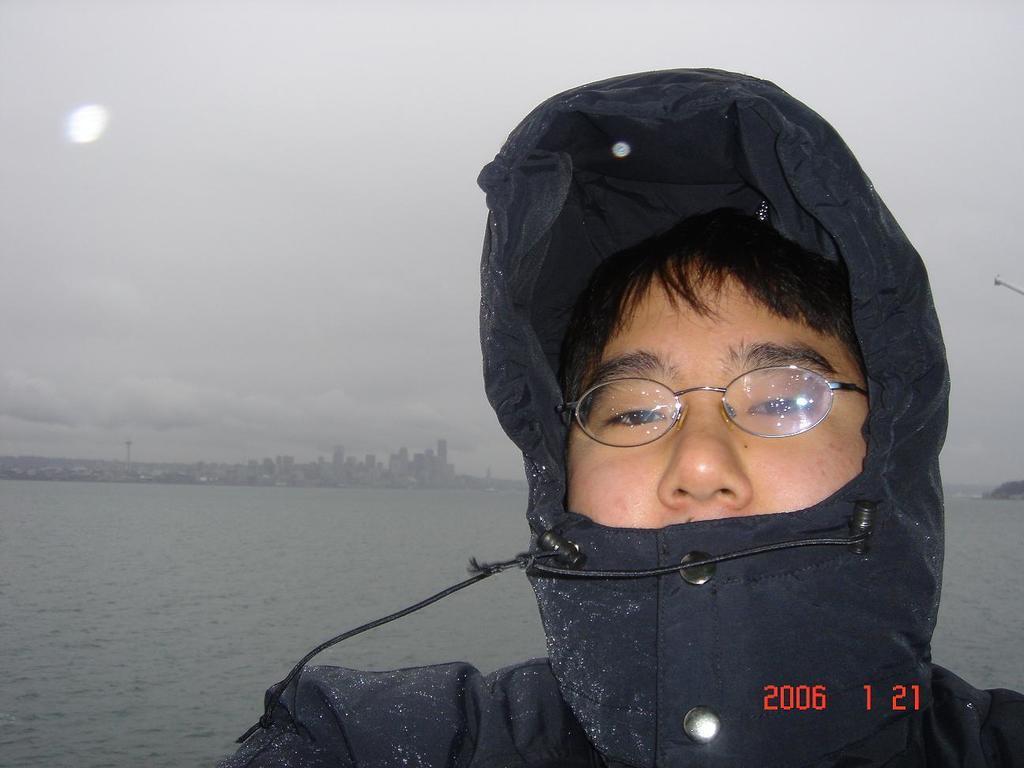Describe this image in one or two sentences. In this image I can see a person wearing black color dress. Back I can see few buildings and water. The sky is cloudy. 